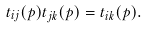<formula> <loc_0><loc_0><loc_500><loc_500>t _ { i j } ( p ) t _ { j k } ( p ) = t _ { i k } ( p ) .</formula> 